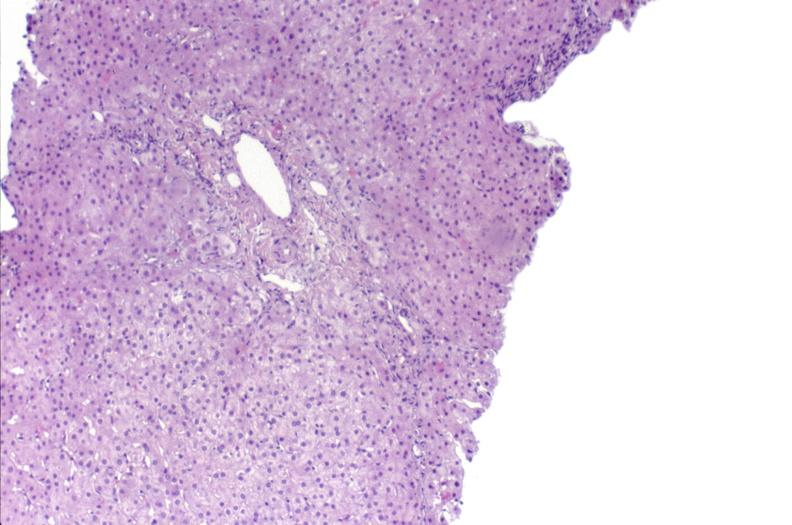s normal ovary present?
Answer the question using a single word or phrase. No 